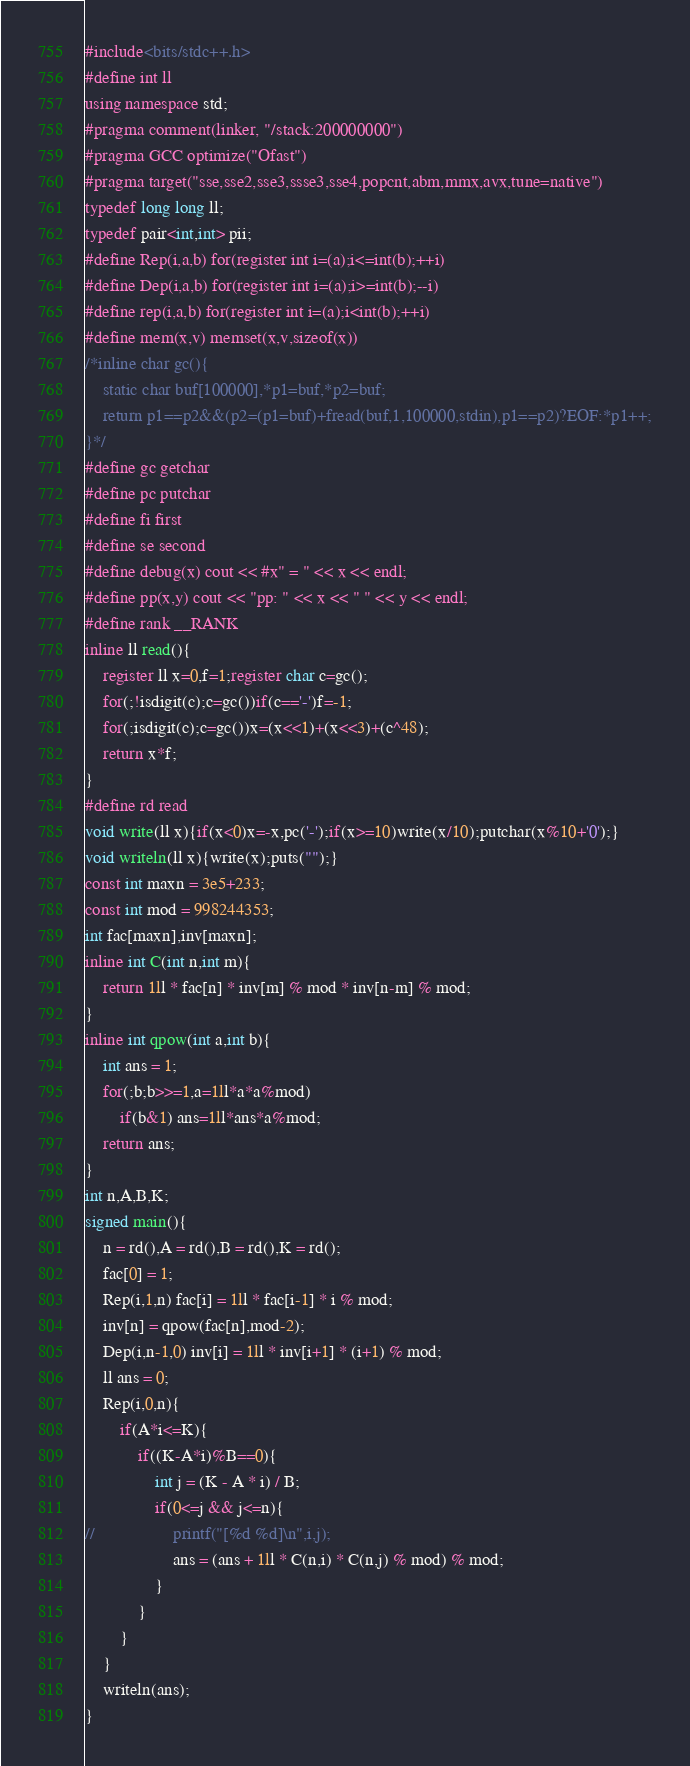<code> <loc_0><loc_0><loc_500><loc_500><_C++_>#include<bits/stdc++.h>
#define int ll
using namespace std;
#pragma comment(linker, "/stack:200000000")
#pragma GCC optimize("Ofast")
#pragma target("sse,sse2,sse3,ssse3,sse4,popcnt,abm,mmx,avx,tune=native")
typedef long long ll;
typedef pair<int,int> pii;
#define Rep(i,a,b) for(register int i=(a);i<=int(b);++i)
#define Dep(i,a,b) for(register int i=(a);i>=int(b);--i)
#define rep(i,a,b) for(register int i=(a);i<int(b);++i)
#define mem(x,v) memset(x,v,sizeof(x))
/*inline char gc(){
    static char buf[100000],*p1=buf,*p2=buf;
    return p1==p2&&(p2=(p1=buf)+fread(buf,1,100000,stdin),p1==p2)?EOF:*p1++;
}*/
#define gc getchar
#define pc putchar
#define fi first
#define se second
#define debug(x) cout << #x" = " << x << endl;
#define pp(x,y) cout << "pp: " << x << " " << y << endl;
#define rank __RANK
inline ll read(){
	register ll x=0,f=1;register char c=gc();
	for(;!isdigit(c);c=gc())if(c=='-')f=-1;
	for(;isdigit(c);c=gc())x=(x<<1)+(x<<3)+(c^48);
	return x*f;
}
#define rd read
void write(ll x){if(x<0)x=-x,pc('-');if(x>=10)write(x/10);putchar(x%10+'0');}
void writeln(ll x){write(x);puts("");}
const int maxn = 3e5+233;
const int mod = 998244353;
int fac[maxn],inv[maxn];
inline int C(int n,int m){
	return 1ll * fac[n] * inv[m] % mod * inv[n-m] % mod;
}
inline int qpow(int a,int b){
	int ans = 1;
	for(;b;b>>=1,a=1ll*a*a%mod)
		if(b&1) ans=1ll*ans*a%mod;
	return ans;
}
int n,A,B,K; 
signed main(){
	n = rd(),A = rd(),B = rd(),K = rd();
	fac[0] = 1;
	Rep(i,1,n) fac[i] = 1ll * fac[i-1] * i % mod;
	inv[n] = qpow(fac[n],mod-2);
	Dep(i,n-1,0) inv[i] = 1ll * inv[i+1] * (i+1) % mod; 
	ll ans = 0;
	Rep(i,0,n){
		if(A*i<=K){
			if((K-A*i)%B==0){
				int j = (K - A * i) / B;
				if(0<=j && j<=n){
//					printf("[%d %d]\n",i,j);
					ans = (ans + 1ll * C(n,i) * C(n,j) % mod) % mod;
				}
			}
		}
	} 
	writeln(ans);
}
</code> 